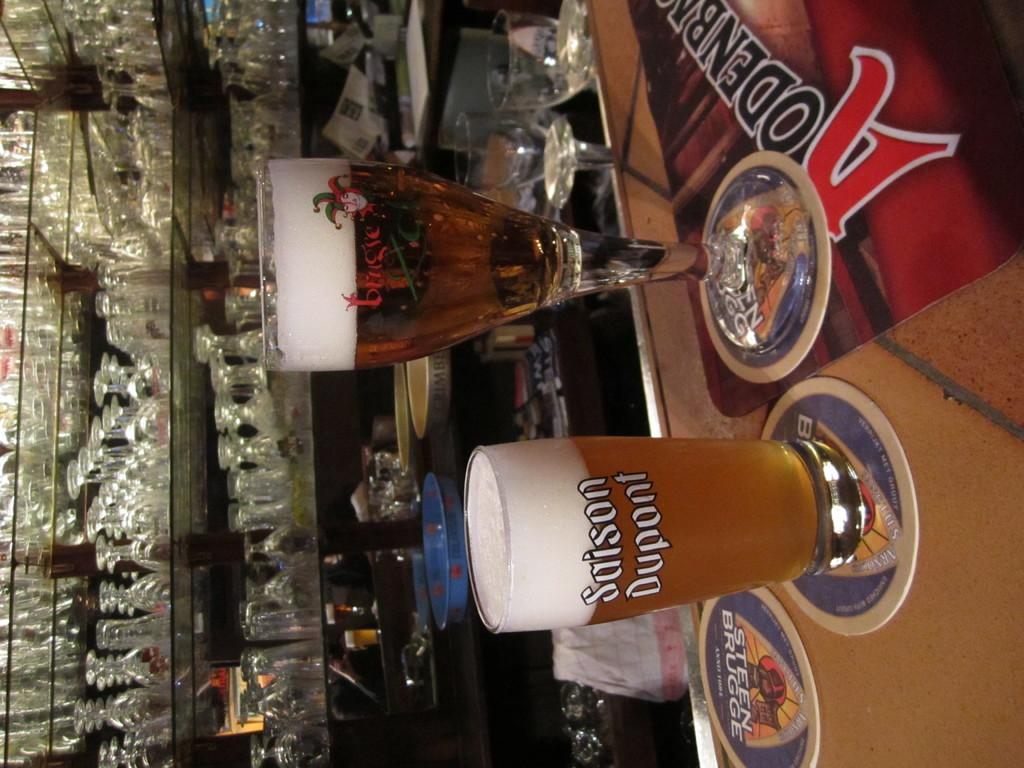<image>
Give a short and clear explanation of the subsequent image. A glass with Sason Dupont is full to the brim with beer. 